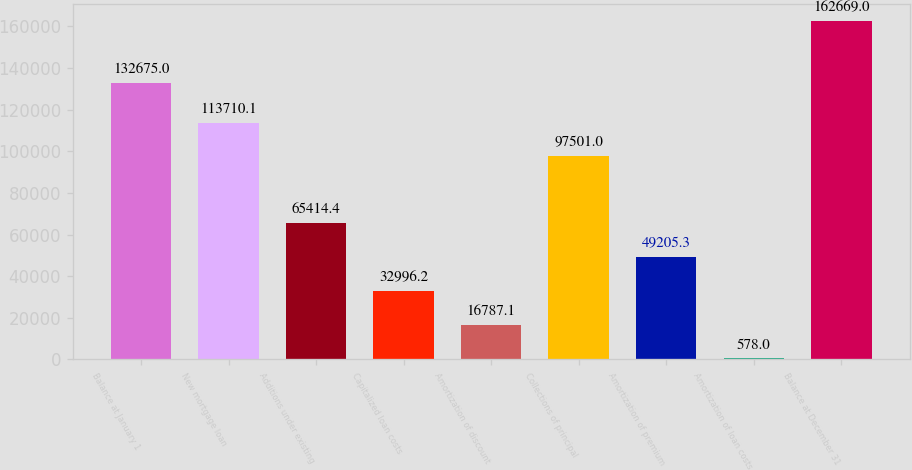Convert chart. <chart><loc_0><loc_0><loc_500><loc_500><bar_chart><fcel>Balance at January 1<fcel>New mortgage loan<fcel>Additions under existing<fcel>Capitalized loan costs<fcel>Amortization of discount<fcel>Collections of principal<fcel>Amortization of premium<fcel>Amortization of loan costs<fcel>Balance at December 31<nl><fcel>132675<fcel>113710<fcel>65414.4<fcel>32996.2<fcel>16787.1<fcel>97501<fcel>49205.3<fcel>578<fcel>162669<nl></chart> 